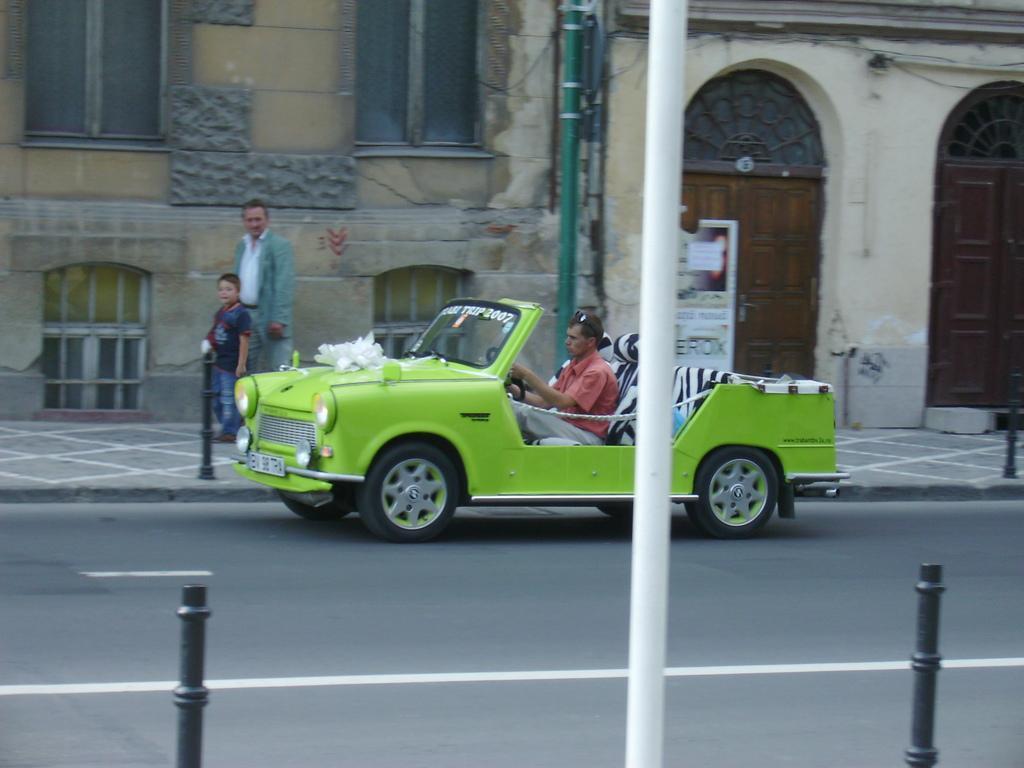In one or two sentences, can you explain what this image depicts? In this image there is a person driving a car on the road, beside the road on the pavement there is a child and a person walking, behind them them is a building. 